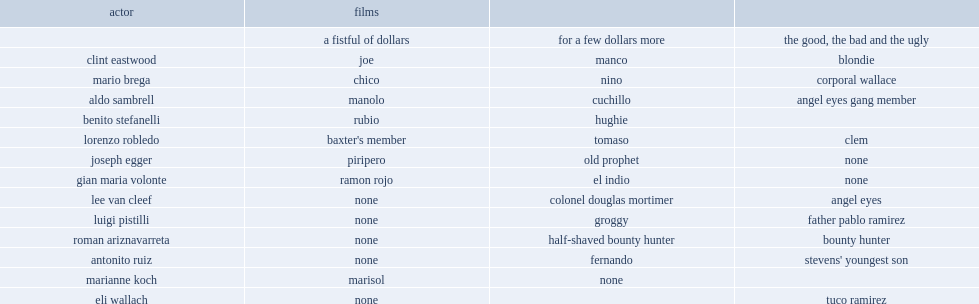List the names of the films respecetively. A fistful of dollars for a few dollars more the good, the bad and the ugly. 